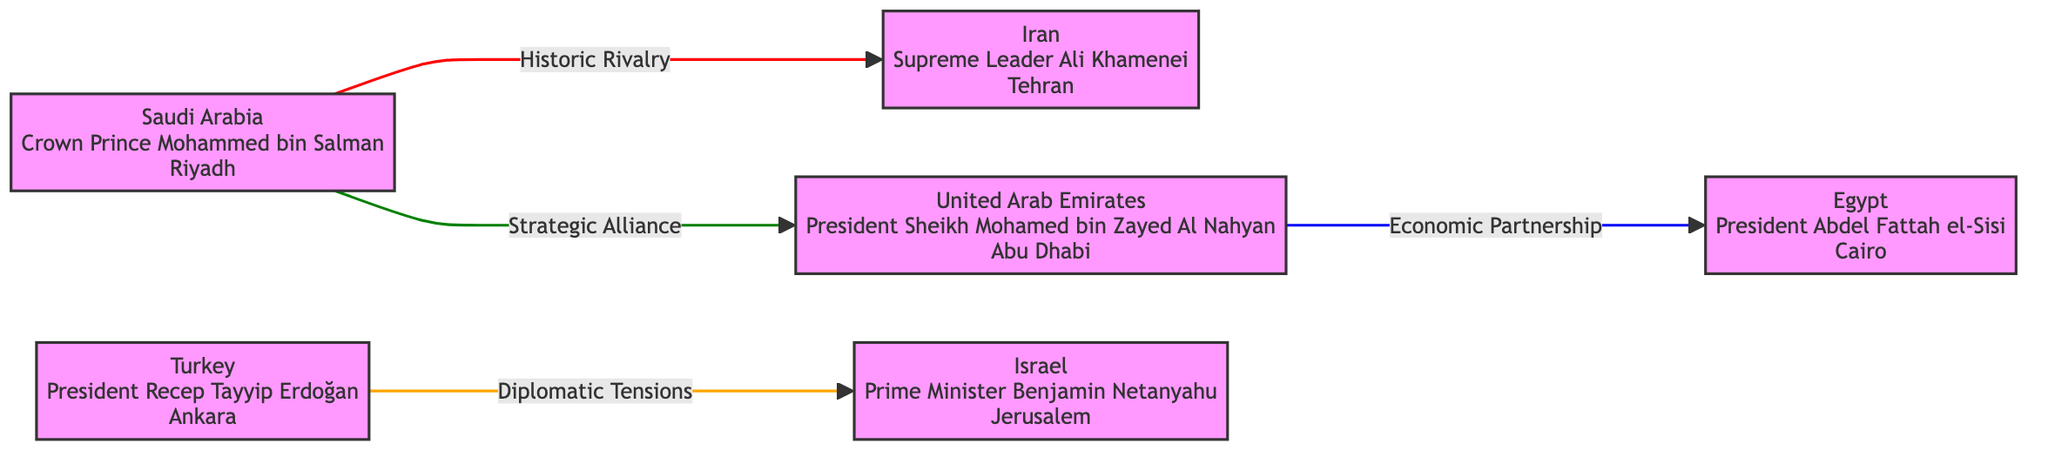What is the capital of Turkey? The diagram lists Turkey as a node with "Ankara" designated as its capital. This information is directly visible in the node associated with Turkey.
Answer: Ankara Who is the Prime Minister of Israel? The label on the node for Israel specifies "Prime Minister Benjamin Netanyahu." This direct association provides the required information.
Answer: Benjamin Netanyahu How many countries are represented in the diagram? The diagram has six nodes, each representing a different country. By counting the nodes, we determine the number of countries.
Answer: 6 What type of relationship exists between Saudi Arabia and Iran? The link between Saudi Arabia and Iran is labeled as "Historic Rivalry." This is a direct specification from the relationship line connecting the two nodes.
Answer: Historic Rivalry Which two countries have an economic partnership? The link from the United Arab Emirates to Egypt indicates an "Economic Partnership." By examining these nodes and their connection, we find the countries involved.
Answer: United Arab Emirates and Egypt What is the relationship between Turkey and Israel? The diagram represents the relationship between Turkey and Israel as "Diplomatic Tensions," visible in the connecting line and label between their respective nodes.
Answer: Diplomatic Tensions Which country is depicted as a strategic ally to Saudi Arabia? The node for the United Arab Emirates shows a strategic alliance to Saudi Arabia, indicated by the relationship line connecting these two nodes.
Answer: United Arab Emirates List the color coded representation for Iran. In the diagram, Iran is represented with a fill color of light green (#98FB98), which is specified in the styling for the node.
Answer: light green What is the relationship color between Saudi Arabia and Iran? The relationship is colored in red, with a stroke style specifically indicated for the link between these two nodes. This is noted in the link style definitions within the diagram.
Answer: red 